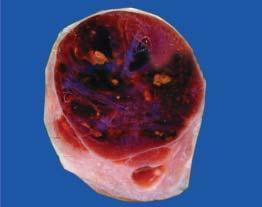what does cut section show?
Answer the question using a single word or phrase. Lobules of translucent gelatinous light brown parenchyma and areas of haemorrhage 